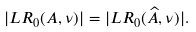<formula> <loc_0><loc_0><loc_500><loc_500>| { L R } _ { 0 } ( A , \nu ) | = | { L R } _ { 0 } ( { \widehat { A } } , \nu ) | .</formula> 